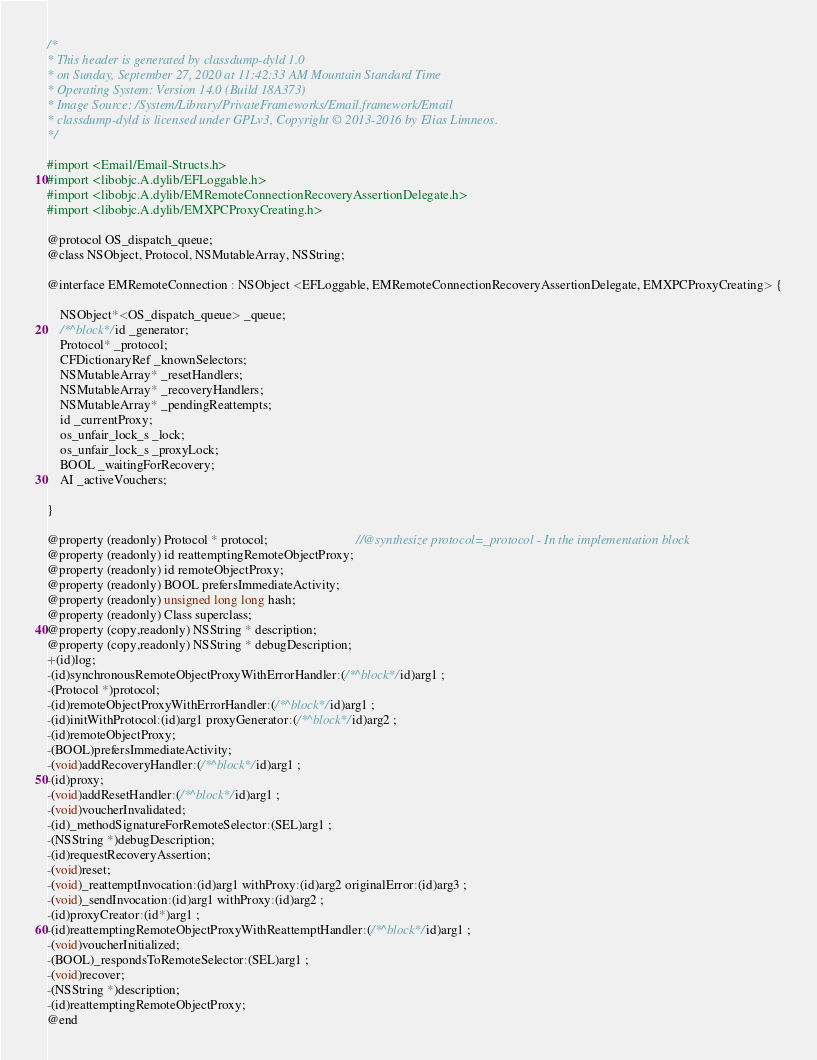<code> <loc_0><loc_0><loc_500><loc_500><_C_>/*
* This header is generated by classdump-dyld 1.0
* on Sunday, September 27, 2020 at 11:42:33 AM Mountain Standard Time
* Operating System: Version 14.0 (Build 18A373)
* Image Source: /System/Library/PrivateFrameworks/Email.framework/Email
* classdump-dyld is licensed under GPLv3, Copyright © 2013-2016 by Elias Limneos.
*/

#import <Email/Email-Structs.h>
#import <libobjc.A.dylib/EFLoggable.h>
#import <libobjc.A.dylib/EMRemoteConnectionRecoveryAssertionDelegate.h>
#import <libobjc.A.dylib/EMXPCProxyCreating.h>

@protocol OS_dispatch_queue;
@class NSObject, Protocol, NSMutableArray, NSString;

@interface EMRemoteConnection : NSObject <EFLoggable, EMRemoteConnectionRecoveryAssertionDelegate, EMXPCProxyCreating> {

	NSObject*<OS_dispatch_queue> _queue;
	/*^block*/id _generator;
	Protocol* _protocol;
	CFDictionaryRef _knownSelectors;
	NSMutableArray* _resetHandlers;
	NSMutableArray* _recoveryHandlers;
	NSMutableArray* _pendingReattempts;
	id _currentProxy;
	os_unfair_lock_s _lock;
	os_unfair_lock_s _proxyLock;
	BOOL _waitingForRecovery;
	AI _activeVouchers;

}

@property (readonly) Protocol * protocol;                           //@synthesize protocol=_protocol - In the implementation block
@property (readonly) id reattemptingRemoteObjectProxy; 
@property (readonly) id remoteObjectProxy; 
@property (readonly) BOOL prefersImmediateActivity; 
@property (readonly) unsigned long long hash; 
@property (readonly) Class superclass; 
@property (copy,readonly) NSString * description; 
@property (copy,readonly) NSString * debugDescription; 
+(id)log;
-(id)synchronousRemoteObjectProxyWithErrorHandler:(/*^block*/id)arg1 ;
-(Protocol *)protocol;
-(id)remoteObjectProxyWithErrorHandler:(/*^block*/id)arg1 ;
-(id)initWithProtocol:(id)arg1 proxyGenerator:(/*^block*/id)arg2 ;
-(id)remoteObjectProxy;
-(BOOL)prefersImmediateActivity;
-(void)addRecoveryHandler:(/*^block*/id)arg1 ;
-(id)proxy;
-(void)addResetHandler:(/*^block*/id)arg1 ;
-(void)voucherInvalidated;
-(id)_methodSignatureForRemoteSelector:(SEL)arg1 ;
-(NSString *)debugDescription;
-(id)requestRecoveryAssertion;
-(void)reset;
-(void)_reattemptInvocation:(id)arg1 withProxy:(id)arg2 originalError:(id)arg3 ;
-(void)_sendInvocation:(id)arg1 withProxy:(id)arg2 ;
-(id)proxyCreator:(id*)arg1 ;
-(id)reattemptingRemoteObjectProxyWithReattemptHandler:(/*^block*/id)arg1 ;
-(void)voucherInitialized;
-(BOOL)_respondsToRemoteSelector:(SEL)arg1 ;
-(void)recover;
-(NSString *)description;
-(id)reattemptingRemoteObjectProxy;
@end

</code> 